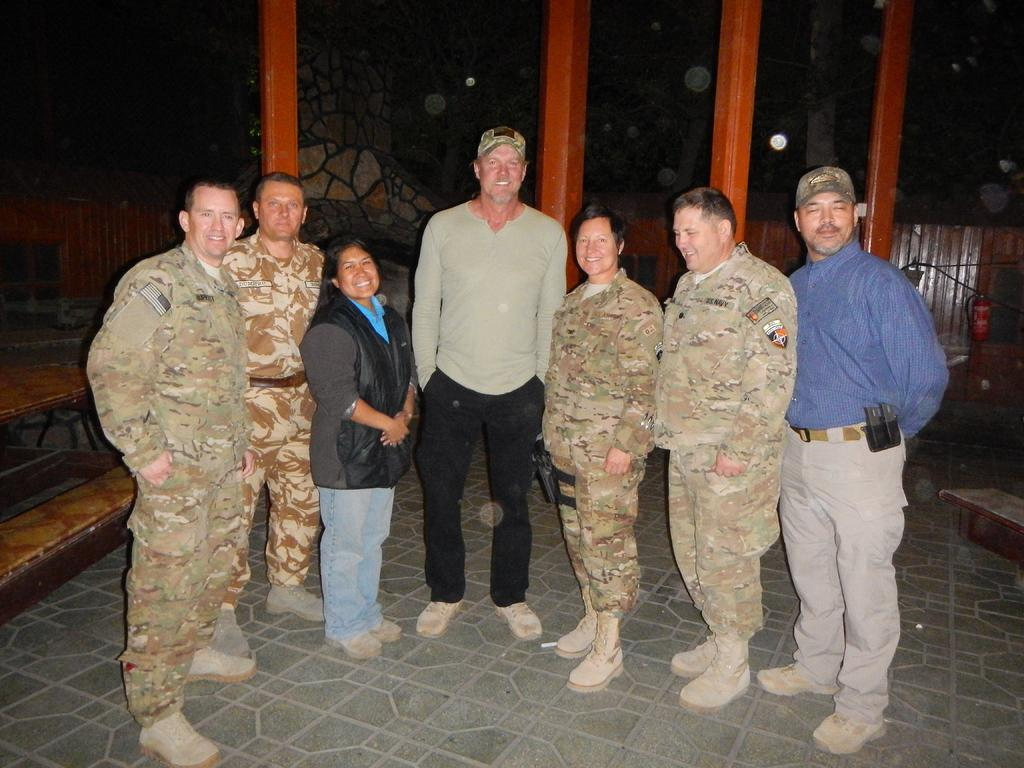How many people are in the image? There is a group of people in the image, but the exact number is not specified. What are the people in the image doing? The people are on the ground, but their specific activity is not mentioned. What can be seen in the background of the image? In the background of the image, there are pillars, benches, and some unspecified objects. What type of sea creatures can be seen swimming near the people in the image? There is no sea or sea creatures present in the image; it features a group of people on the ground with a background containing pillars, benches, and unspecified objects. 